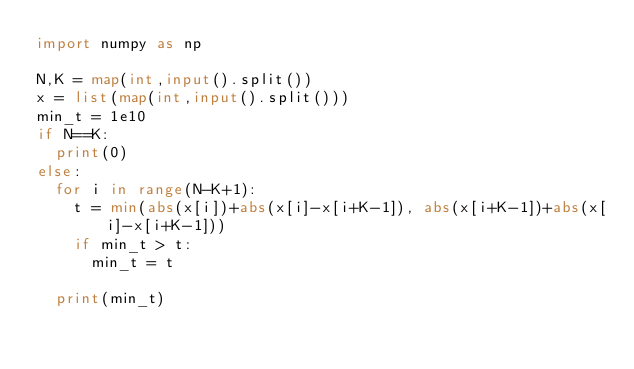<code> <loc_0><loc_0><loc_500><loc_500><_Python_>import numpy as np

N,K = map(int,input().split())
x = list(map(int,input().split()))
min_t = 1e10
if N==K:
  print(0)
else:
  for i in range(N-K+1):
    t = min(abs(x[i])+abs(x[i]-x[i+K-1]), abs(x[i+K-1])+abs(x[i]-x[i+K-1]))
    if min_t > t:
      min_t = t

  print(min_t)

</code> 